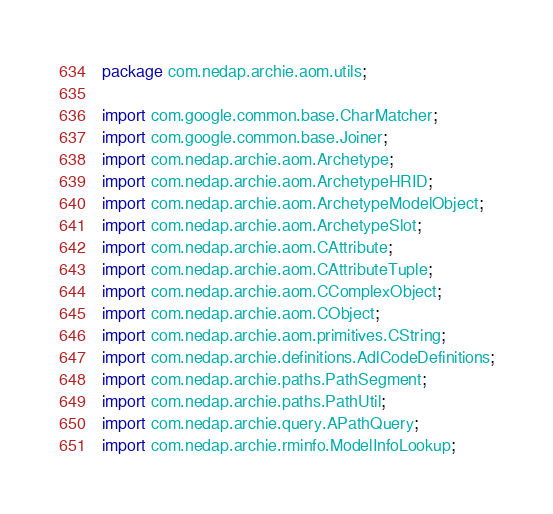<code> <loc_0><loc_0><loc_500><loc_500><_Java_>package com.nedap.archie.aom.utils;

import com.google.common.base.CharMatcher;
import com.google.common.base.Joiner;
import com.nedap.archie.aom.Archetype;
import com.nedap.archie.aom.ArchetypeHRID;
import com.nedap.archie.aom.ArchetypeModelObject;
import com.nedap.archie.aom.ArchetypeSlot;
import com.nedap.archie.aom.CAttribute;
import com.nedap.archie.aom.CAttributeTuple;
import com.nedap.archie.aom.CComplexObject;
import com.nedap.archie.aom.CObject;
import com.nedap.archie.aom.primitives.CString;
import com.nedap.archie.definitions.AdlCodeDefinitions;
import com.nedap.archie.paths.PathSegment;
import com.nedap.archie.paths.PathUtil;
import com.nedap.archie.query.APathQuery;
import com.nedap.archie.rminfo.ModelInfoLookup;</code> 